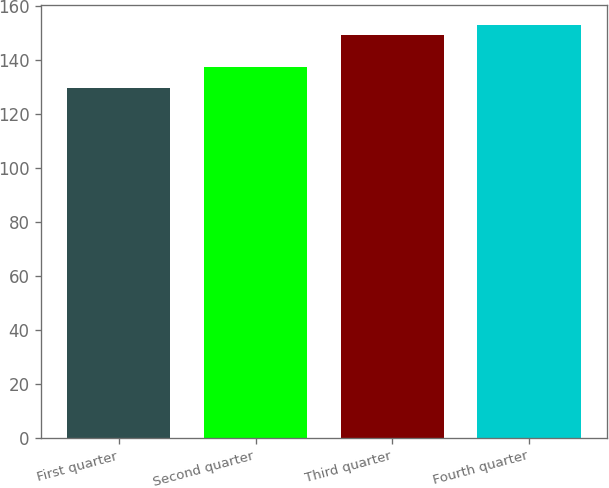Convert chart to OTSL. <chart><loc_0><loc_0><loc_500><loc_500><bar_chart><fcel>First quarter<fcel>Second quarter<fcel>Third quarter<fcel>Fourth quarter<nl><fcel>129.62<fcel>137.29<fcel>149.28<fcel>152.83<nl></chart> 